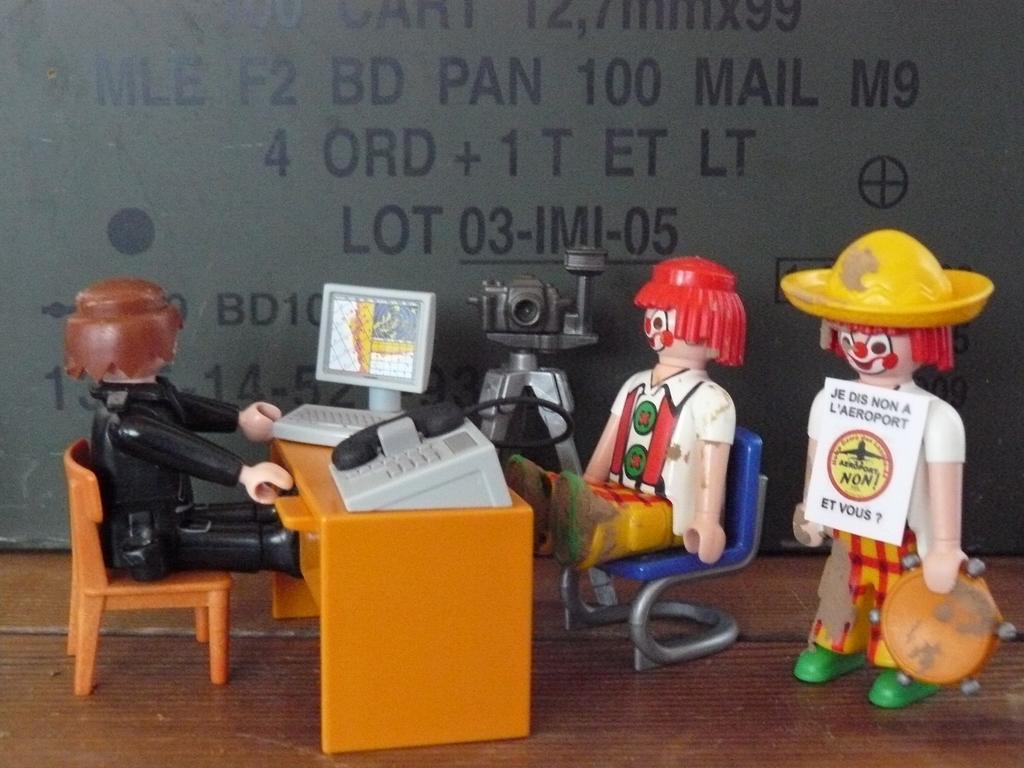In one or two sentences, can you explain what this image depicts? These toys are sitting on the chair. This toy standing. We can see table,mobile,monitor,keyboard,camera. 